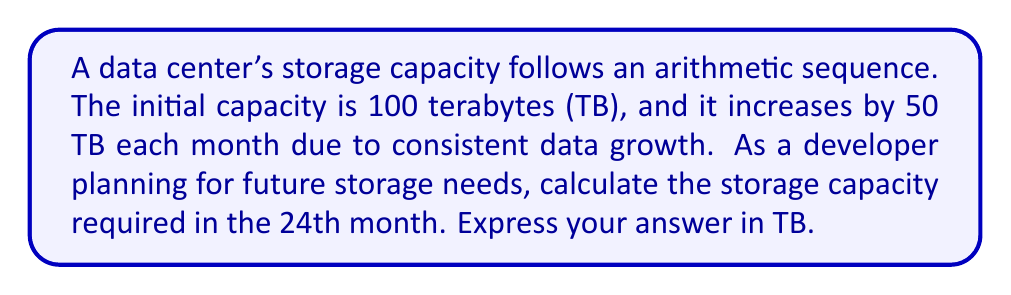Can you answer this question? To solve this problem, we'll use the arithmetic sequence formula:

$$a_n = a_1 + (n - 1)d$$

Where:
$a_n$ = the nth term of the sequence (storage capacity in the 24th month)
$a_1$ = the first term (initial storage capacity)
$n$ = the position of the term we're calculating
$d$ = the common difference (monthly increase in storage)

Given:
$a_1 = 100$ TB (initial capacity)
$d = 50$ TB (monthly increase)
$n = 24$ (we want to find the 24th term)

Let's substitute these values into the formula:

$$a_{24} = 100 + (24 - 1)50$$

Simplify:
$$a_{24} = 100 + (23)50$$
$$a_{24} = 100 + 1150$$
$$a_{24} = 1250$$

Therefore, the storage capacity required in the 24th month will be 1250 TB.
Answer: 1250 TB 